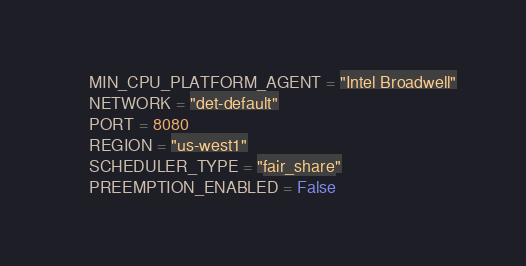Convert code to text. <code><loc_0><loc_0><loc_500><loc_500><_Python_>    MIN_CPU_PLATFORM_AGENT = "Intel Broadwell"
    NETWORK = "det-default"
    PORT = 8080
    REGION = "us-west1"
    SCHEDULER_TYPE = "fair_share"
    PREEMPTION_ENABLED = False
</code> 